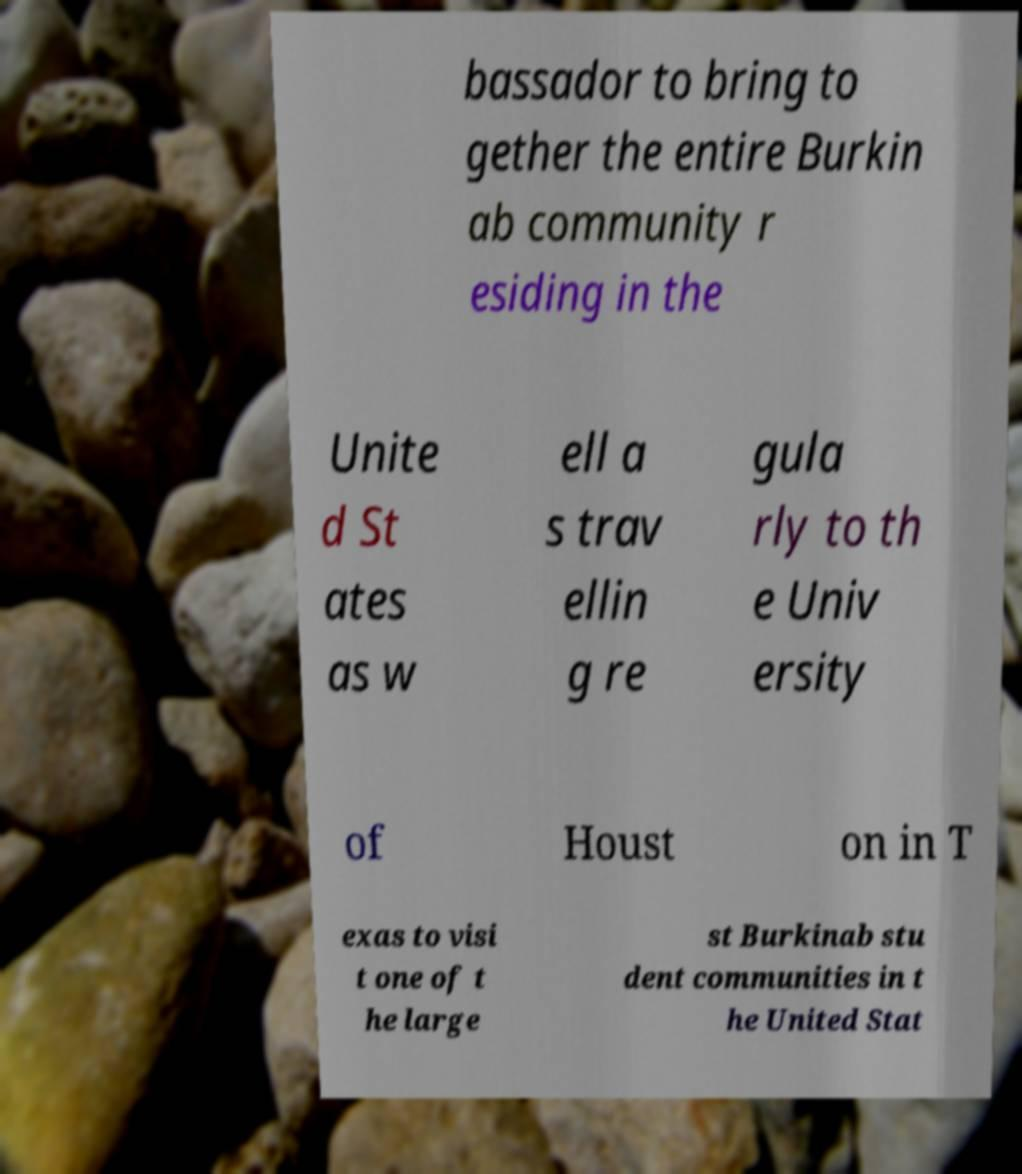For documentation purposes, I need the text within this image transcribed. Could you provide that? bassador to bring to gether the entire Burkin ab community r esiding in the Unite d St ates as w ell a s trav ellin g re gula rly to th e Univ ersity of Houst on in T exas to visi t one of t he large st Burkinab stu dent communities in t he United Stat 